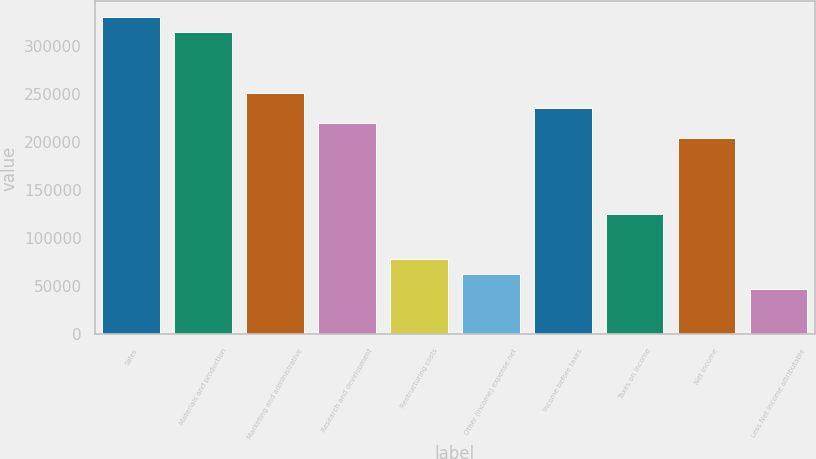<chart> <loc_0><loc_0><loc_500><loc_500><bar_chart><fcel>Sales<fcel>Materials and production<fcel>Marketing and administrative<fcel>Research and development<fcel>Restructuring costs<fcel>Other (income) expense net<fcel>Income before taxes<fcel>Taxes on income<fcel>Net income<fcel>Less Net income attributable<nl><fcel>330538<fcel>314798<fcel>251839<fcel>220359<fcel>78700.8<fcel>62961<fcel>236099<fcel>125920<fcel>204619<fcel>47221.2<nl></chart> 